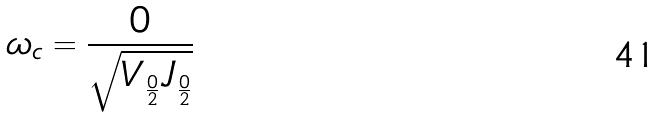<formula> <loc_0><loc_0><loc_500><loc_500>\omega _ { c } = \frac { 0 } { \sqrt { V _ { \frac { 0 } { 2 } } J _ { \frac { 0 } { 2 } } } }</formula> 